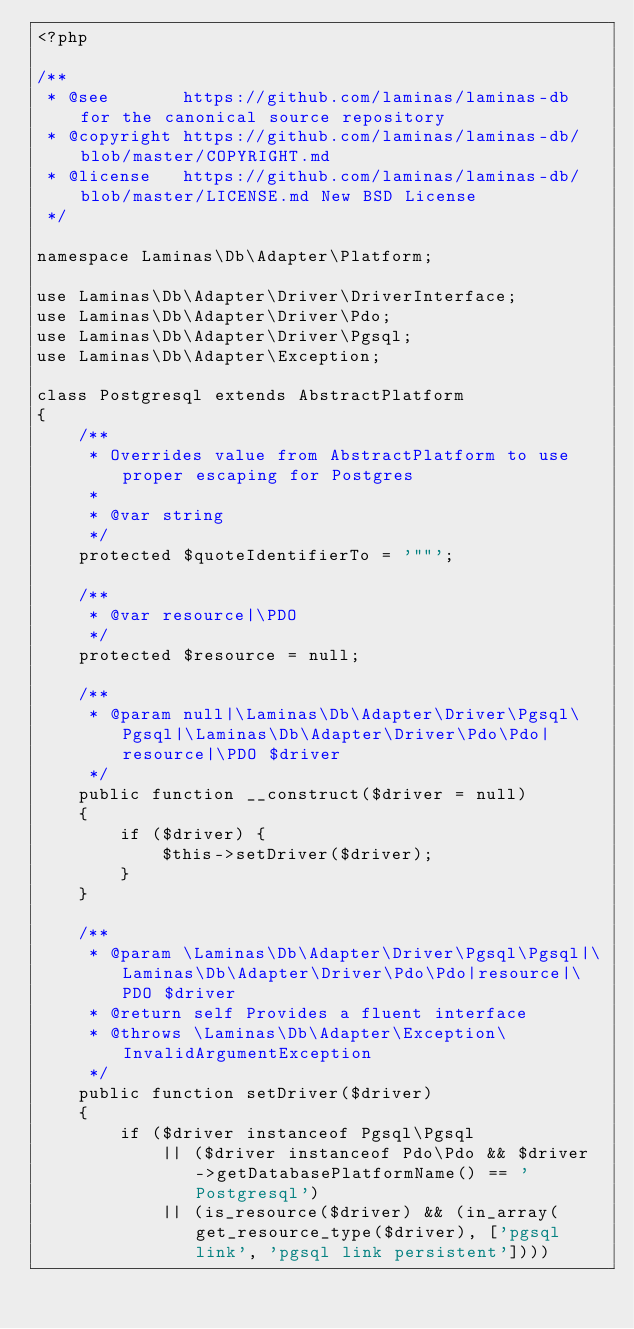Convert code to text. <code><loc_0><loc_0><loc_500><loc_500><_PHP_><?php

/**
 * @see       https://github.com/laminas/laminas-db for the canonical source repository
 * @copyright https://github.com/laminas/laminas-db/blob/master/COPYRIGHT.md
 * @license   https://github.com/laminas/laminas-db/blob/master/LICENSE.md New BSD License
 */

namespace Laminas\Db\Adapter\Platform;

use Laminas\Db\Adapter\Driver\DriverInterface;
use Laminas\Db\Adapter\Driver\Pdo;
use Laminas\Db\Adapter\Driver\Pgsql;
use Laminas\Db\Adapter\Exception;

class Postgresql extends AbstractPlatform
{
    /**
     * Overrides value from AbstractPlatform to use proper escaping for Postgres
     *
     * @var string
     */
    protected $quoteIdentifierTo = '""';

    /**
     * @var resource|\PDO
     */
    protected $resource = null;

    /**
     * @param null|\Laminas\Db\Adapter\Driver\Pgsql\Pgsql|\Laminas\Db\Adapter\Driver\Pdo\Pdo|resource|\PDO $driver
     */
    public function __construct($driver = null)
    {
        if ($driver) {
            $this->setDriver($driver);
        }
    }

    /**
     * @param \Laminas\Db\Adapter\Driver\Pgsql\Pgsql|\Laminas\Db\Adapter\Driver\Pdo\Pdo|resource|\PDO $driver
     * @return self Provides a fluent interface
     * @throws \Laminas\Db\Adapter\Exception\InvalidArgumentException
     */
    public function setDriver($driver)
    {
        if ($driver instanceof Pgsql\Pgsql
            || ($driver instanceof Pdo\Pdo && $driver->getDatabasePlatformName() == 'Postgresql')
            || (is_resource($driver) && (in_array(get_resource_type($driver), ['pgsql link', 'pgsql link persistent'])))</code> 